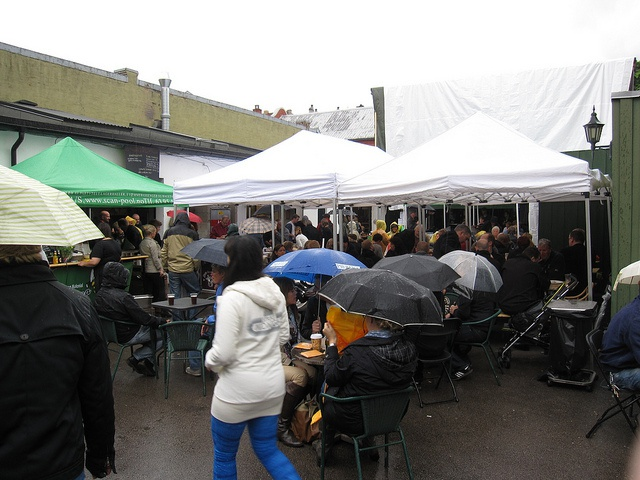Describe the objects in this image and their specific colors. I can see people in white, black, and gray tones, people in white, black, gray, and maroon tones, people in white, lightgray, darkgray, navy, and black tones, umbrella in white, darkgray, and gray tones, and umbrella in white, darkgray, and lightgray tones in this image. 